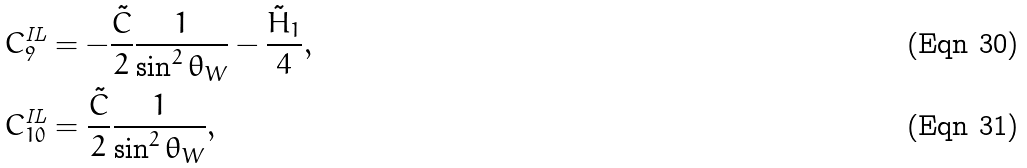Convert formula to latex. <formula><loc_0><loc_0><loc_500><loc_500>C _ { 9 } ^ { \text {IL} } & = - \frac { \tilde { C } } { 2 } \frac { 1 } { \sin ^ { 2 } \theta _ { W } } - \frac { \tilde { H } _ { 1 } } { 4 } , \\ C _ { 1 0 } ^ { \text {IL} } & = \frac { \tilde { C } } { 2 } \frac { 1 } { \sin ^ { 2 } \theta _ { W } } ,</formula> 